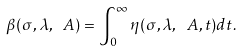<formula> <loc_0><loc_0><loc_500><loc_500>\beta ( \sigma , \lambda , \ A ) = \int _ { 0 } ^ { \infty } \eta ( \sigma , \lambda , \ A , t ) d t .</formula> 